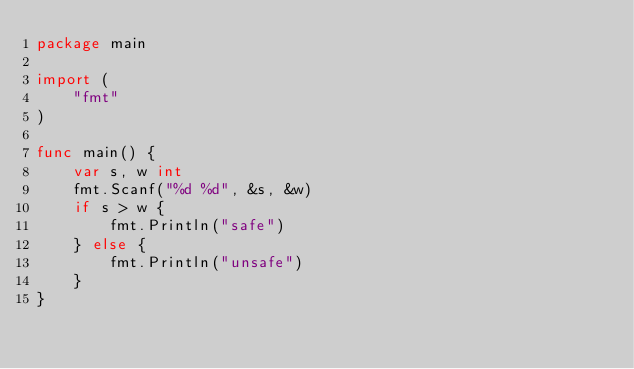Convert code to text. <code><loc_0><loc_0><loc_500><loc_500><_Go_>package main

import (
	"fmt"
)

func main() {
	var s, w int
	fmt.Scanf("%d %d", &s, &w)
	if s > w {
		fmt.Println("safe")
	} else {
		fmt.Println("unsafe")
	}
}
</code> 